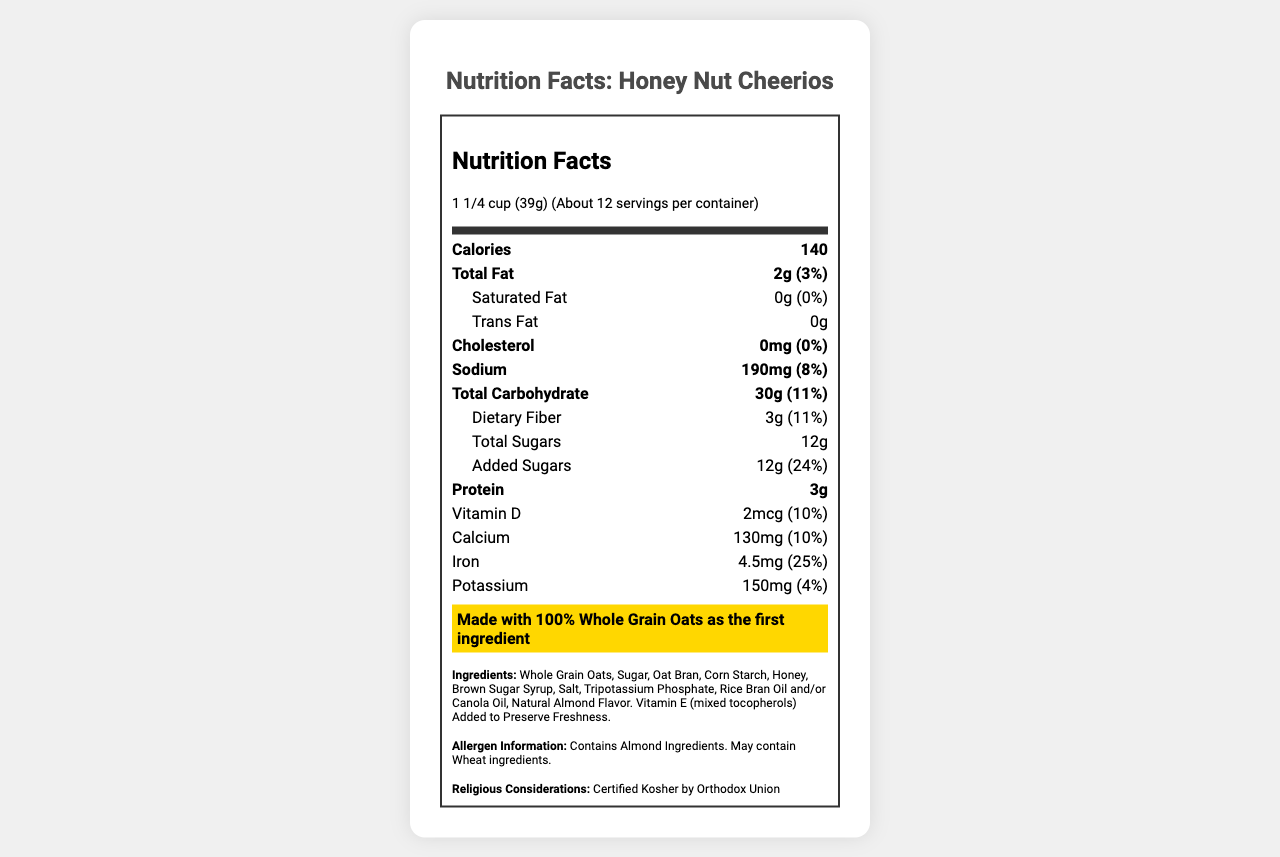what is the serving size? The serving size is mentioned at the top of the Nutrition Facts label as "1 1/4 cup (39g)".
Answer: 1 1/4 cup (39g) how many calories are there per serving? The number of calories per serving is presented right under the serving size information, listed as 140.
Answer: 140 what is the amount of total fat per serving? The amount of total fat per serving is listed right below the calorie information, noted as 2g.
Answer: 2g how much dietary fiber is in one serving? The amount of dietary fiber per serving is found under the total carbohydrate section, listed as 3g.
Answer: 3g what is the daily value percentage for iron? The daily value percentage for iron is shown in the nutrition facts section under the minerals, listed as 25%.
Answer: 25% what ingredient is potentially allergenic in Honey Nut Cheerios? The allergen information box specifies that the product contains almond ingredients.
Answer: Almond Is Honey Nut Cheerios certified Kosher? The document mentions in the religious considerations section that it is certified Kosher by Orthodox Union.
Answer: Yes what is the highlight about whole grains in Honey Nut Cheerios? The document includes a highlighted section stating that Honey Nut Cheerios is "Made with 100% Whole Grain Oats as the first ingredient".
Answer: Made with 100% Whole Grain Oats as the first ingredient which vitamin has the highest daily value percentage? A. Vitamin D B. Calcium C. Folic Acid D. Vitamin B6 Based on the document, folic acid has a 50% daily value percentage, higher than vitamin D (10%), calcium (10%), and Vitamin B6 (30%).
Answer: C. Folic Acid how many grams of added sugars are there per serving? The added sugars are listed under the nutrients section, shown as 12g per serving.
Answer: 12g which nutrient's daily value percentage is the lowest? A. Sodium B. Potassium C. Protein D. Cholesterol Cholesterol has a 0% daily value, which is lower than sodium (8%), potassium (4%), and protein which does not show a daily value percentage.
Answer: D. Cholesterol what is the main source of fat in this cereal? The document lists several ingredients, but it does not specify which one is the main source of fat.
Answer: Cannot be determined summarize the overall nutritional profile of Honey Nut Cheerios. This response covers different aspects of the nutrition label including calories, fat, protein, fiber, sugars, vitamins, minerals, allergen information, and special certifications.
Answer: Honey Nut Cheerios offers a balanced nutritional profile with 140 calories per serving, low total fat (2g), no saturated or trans fat, moderate protein (3g), and a good amount of dietary fiber (3g). Notable highlights include 12g of added sugars, significant whole grain content, and beneficial vitamins and minerals such as vitamin D, calcium, iron, thiamin, riboflavin, niacin, vitamin B6, folic acid, vitamin B12, and zinc. Additionally, it contains almonds and is certified Kosher by the Orthodox Union. 